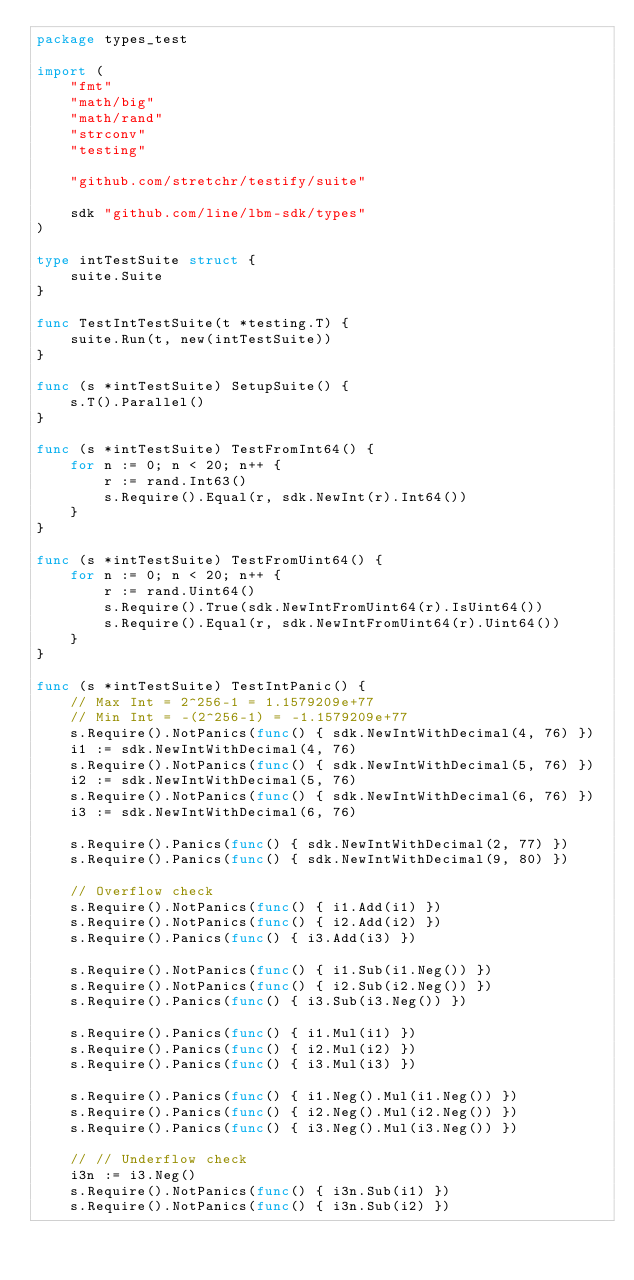<code> <loc_0><loc_0><loc_500><loc_500><_Go_>package types_test

import (
	"fmt"
	"math/big"
	"math/rand"
	"strconv"
	"testing"

	"github.com/stretchr/testify/suite"

	sdk "github.com/line/lbm-sdk/types"
)

type intTestSuite struct {
	suite.Suite
}

func TestIntTestSuite(t *testing.T) {
	suite.Run(t, new(intTestSuite))
}

func (s *intTestSuite) SetupSuite() {
	s.T().Parallel()
}

func (s *intTestSuite) TestFromInt64() {
	for n := 0; n < 20; n++ {
		r := rand.Int63()
		s.Require().Equal(r, sdk.NewInt(r).Int64())
	}
}

func (s *intTestSuite) TestFromUint64() {
	for n := 0; n < 20; n++ {
		r := rand.Uint64()
		s.Require().True(sdk.NewIntFromUint64(r).IsUint64())
		s.Require().Equal(r, sdk.NewIntFromUint64(r).Uint64())
	}
}

func (s *intTestSuite) TestIntPanic() {
	// Max Int = 2^256-1 = 1.1579209e+77
	// Min Int = -(2^256-1) = -1.1579209e+77
	s.Require().NotPanics(func() { sdk.NewIntWithDecimal(4, 76) })
	i1 := sdk.NewIntWithDecimal(4, 76)
	s.Require().NotPanics(func() { sdk.NewIntWithDecimal(5, 76) })
	i2 := sdk.NewIntWithDecimal(5, 76)
	s.Require().NotPanics(func() { sdk.NewIntWithDecimal(6, 76) })
	i3 := sdk.NewIntWithDecimal(6, 76)

	s.Require().Panics(func() { sdk.NewIntWithDecimal(2, 77) })
	s.Require().Panics(func() { sdk.NewIntWithDecimal(9, 80) })

	// Overflow check
	s.Require().NotPanics(func() { i1.Add(i1) })
	s.Require().NotPanics(func() { i2.Add(i2) })
	s.Require().Panics(func() { i3.Add(i3) })

	s.Require().NotPanics(func() { i1.Sub(i1.Neg()) })
	s.Require().NotPanics(func() { i2.Sub(i2.Neg()) })
	s.Require().Panics(func() { i3.Sub(i3.Neg()) })

	s.Require().Panics(func() { i1.Mul(i1) })
	s.Require().Panics(func() { i2.Mul(i2) })
	s.Require().Panics(func() { i3.Mul(i3) })

	s.Require().Panics(func() { i1.Neg().Mul(i1.Neg()) })
	s.Require().Panics(func() { i2.Neg().Mul(i2.Neg()) })
	s.Require().Panics(func() { i3.Neg().Mul(i3.Neg()) })

	// // Underflow check
	i3n := i3.Neg()
	s.Require().NotPanics(func() { i3n.Sub(i1) })
	s.Require().NotPanics(func() { i3n.Sub(i2) })</code> 